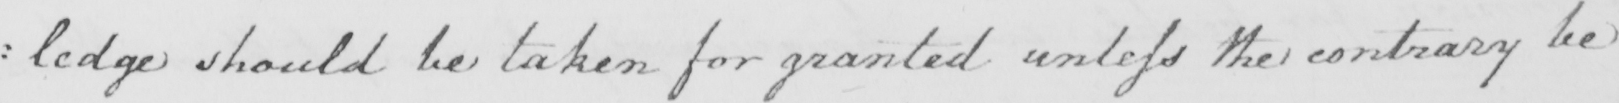What is written in this line of handwriting? : ledge should be taken for granted unless the contrary be 